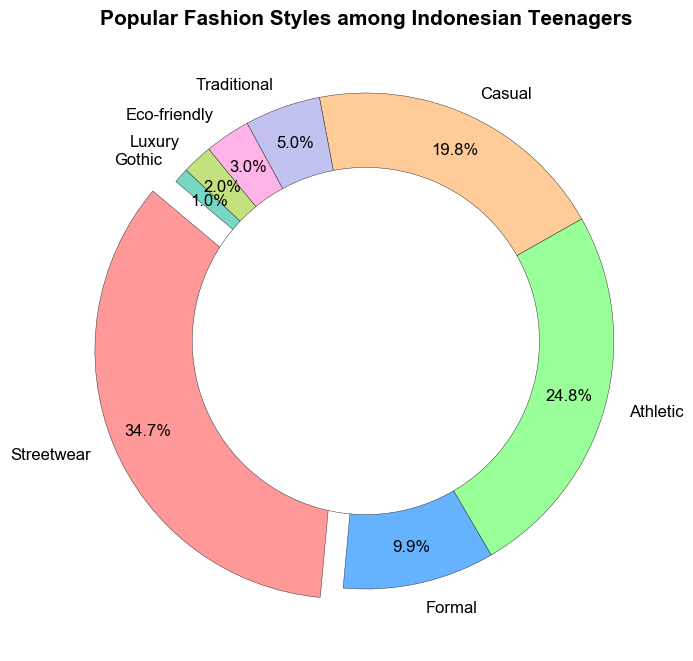What's the most popular fashion style among Indonesian teenagers? The chart shows that Streetwear has the largest slice highlighted in the pie with a percentage of 35%, making it the most popular style.
Answer: Streetwear Which fashion styles together make up half of the pie chart? Adding the percentages of Streetwear (35%) and Athletic (25%), we get a sum of 60%, which is more than half of the pie chart. So, it's just Streetwear.
Answer: Streetwear How much more popular is Streetwear compared to Formal? Streetwear has a percentage of 35%, and Formal has a percentage of 10%. The difference between them is 35% - 10% = 25%.
Answer: 25% What percentage of Indonesian teenagers prefer Casual or Athletic styles? Adding the percentages of Casual (20%) and Athletic (25%), we get a total of 20% + 25% = 45%.
Answer: 45% Which styles are less popular than Casual? The pie chart indicates that Casual holds 20%, while Formal has 10%, Traditional has 5%, Eco-friendly has 3%, Luxury has 2%, and Gothic has 1%. All these are less popular than Casual.
Answer: Formal, Traditional, Eco-friendly, Luxury, Gothic By how much does the percentage of teenagers who favor Athletic styles exceed those who favor Traditional? Athletic has a percentage of 25% while Traditional has 5%. The difference is 25% - 5% = 20%.
Answer: 20% Is Formal more or less popular than Eco-friendly? The percentage for Formal is 10%, and for Eco-friendly, it is 3%. Since 10% is greater than 3%, Formal is more popular.
Answer: More popular Which fashion style occupies the smallest slice in the chart? The smallest slice in the pie chart with a percentage of 1% represents Gothic.
Answer: Gothic How much total percentage do the four least popular styles occupy? Adding the percentages of Traditional (5%), Eco-friendly (3%), Luxury (2%), and Gothic (1%), we get a total of 5% + 3% + 2% + 1% = 11%.
Answer: 11% If you combine Streetwear, Athletic, and Casual styles, what percentage of the chart do they occupy? The combined percentage of Streetwear (35%), Athletic (25%), and Casual (20%) is 35% + 25% + 20% = 80%.
Answer: 80% 